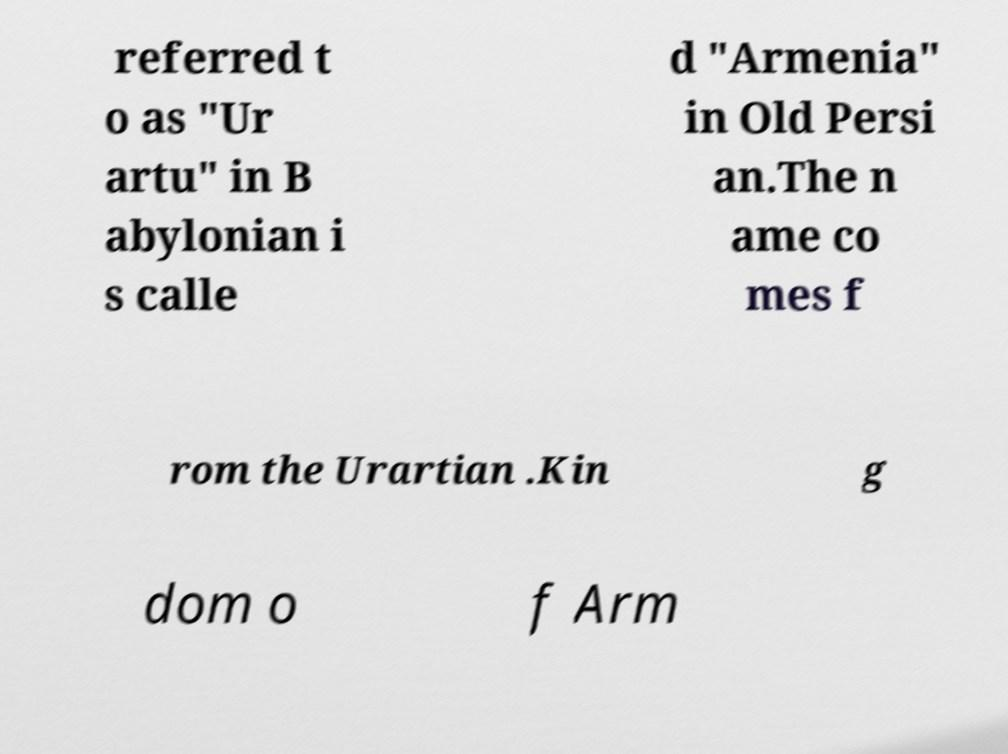There's text embedded in this image that I need extracted. Can you transcribe it verbatim? referred t o as "Ur artu" in B abylonian i s calle d "Armenia" in Old Persi an.The n ame co mes f rom the Urartian .Kin g dom o f Arm 